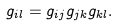<formula> <loc_0><loc_0><loc_500><loc_500>g _ { i l } = g _ { i j } g _ { j k } g _ { k l } .</formula> 